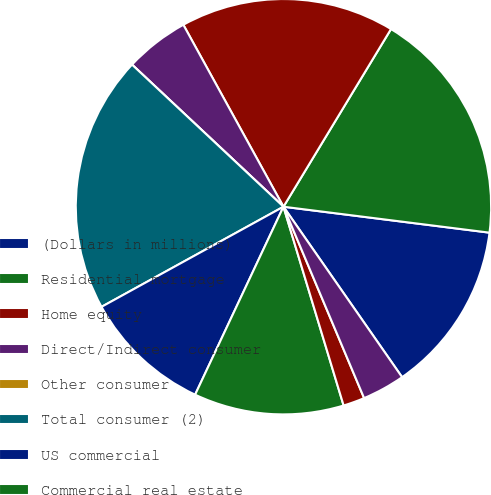Convert chart to OTSL. <chart><loc_0><loc_0><loc_500><loc_500><pie_chart><fcel>(Dollars in millions)<fcel>Residential mortgage<fcel>Home equity<fcel>Direct/Indirect consumer<fcel>Other consumer<fcel>Total consumer (2)<fcel>US commercial<fcel>Commercial real estate<fcel>Commercial lease financing<fcel>Non-US commercial<nl><fcel>13.33%<fcel>18.33%<fcel>16.67%<fcel>5.0%<fcel>0.0%<fcel>20.0%<fcel>10.0%<fcel>11.67%<fcel>1.67%<fcel>3.33%<nl></chart> 